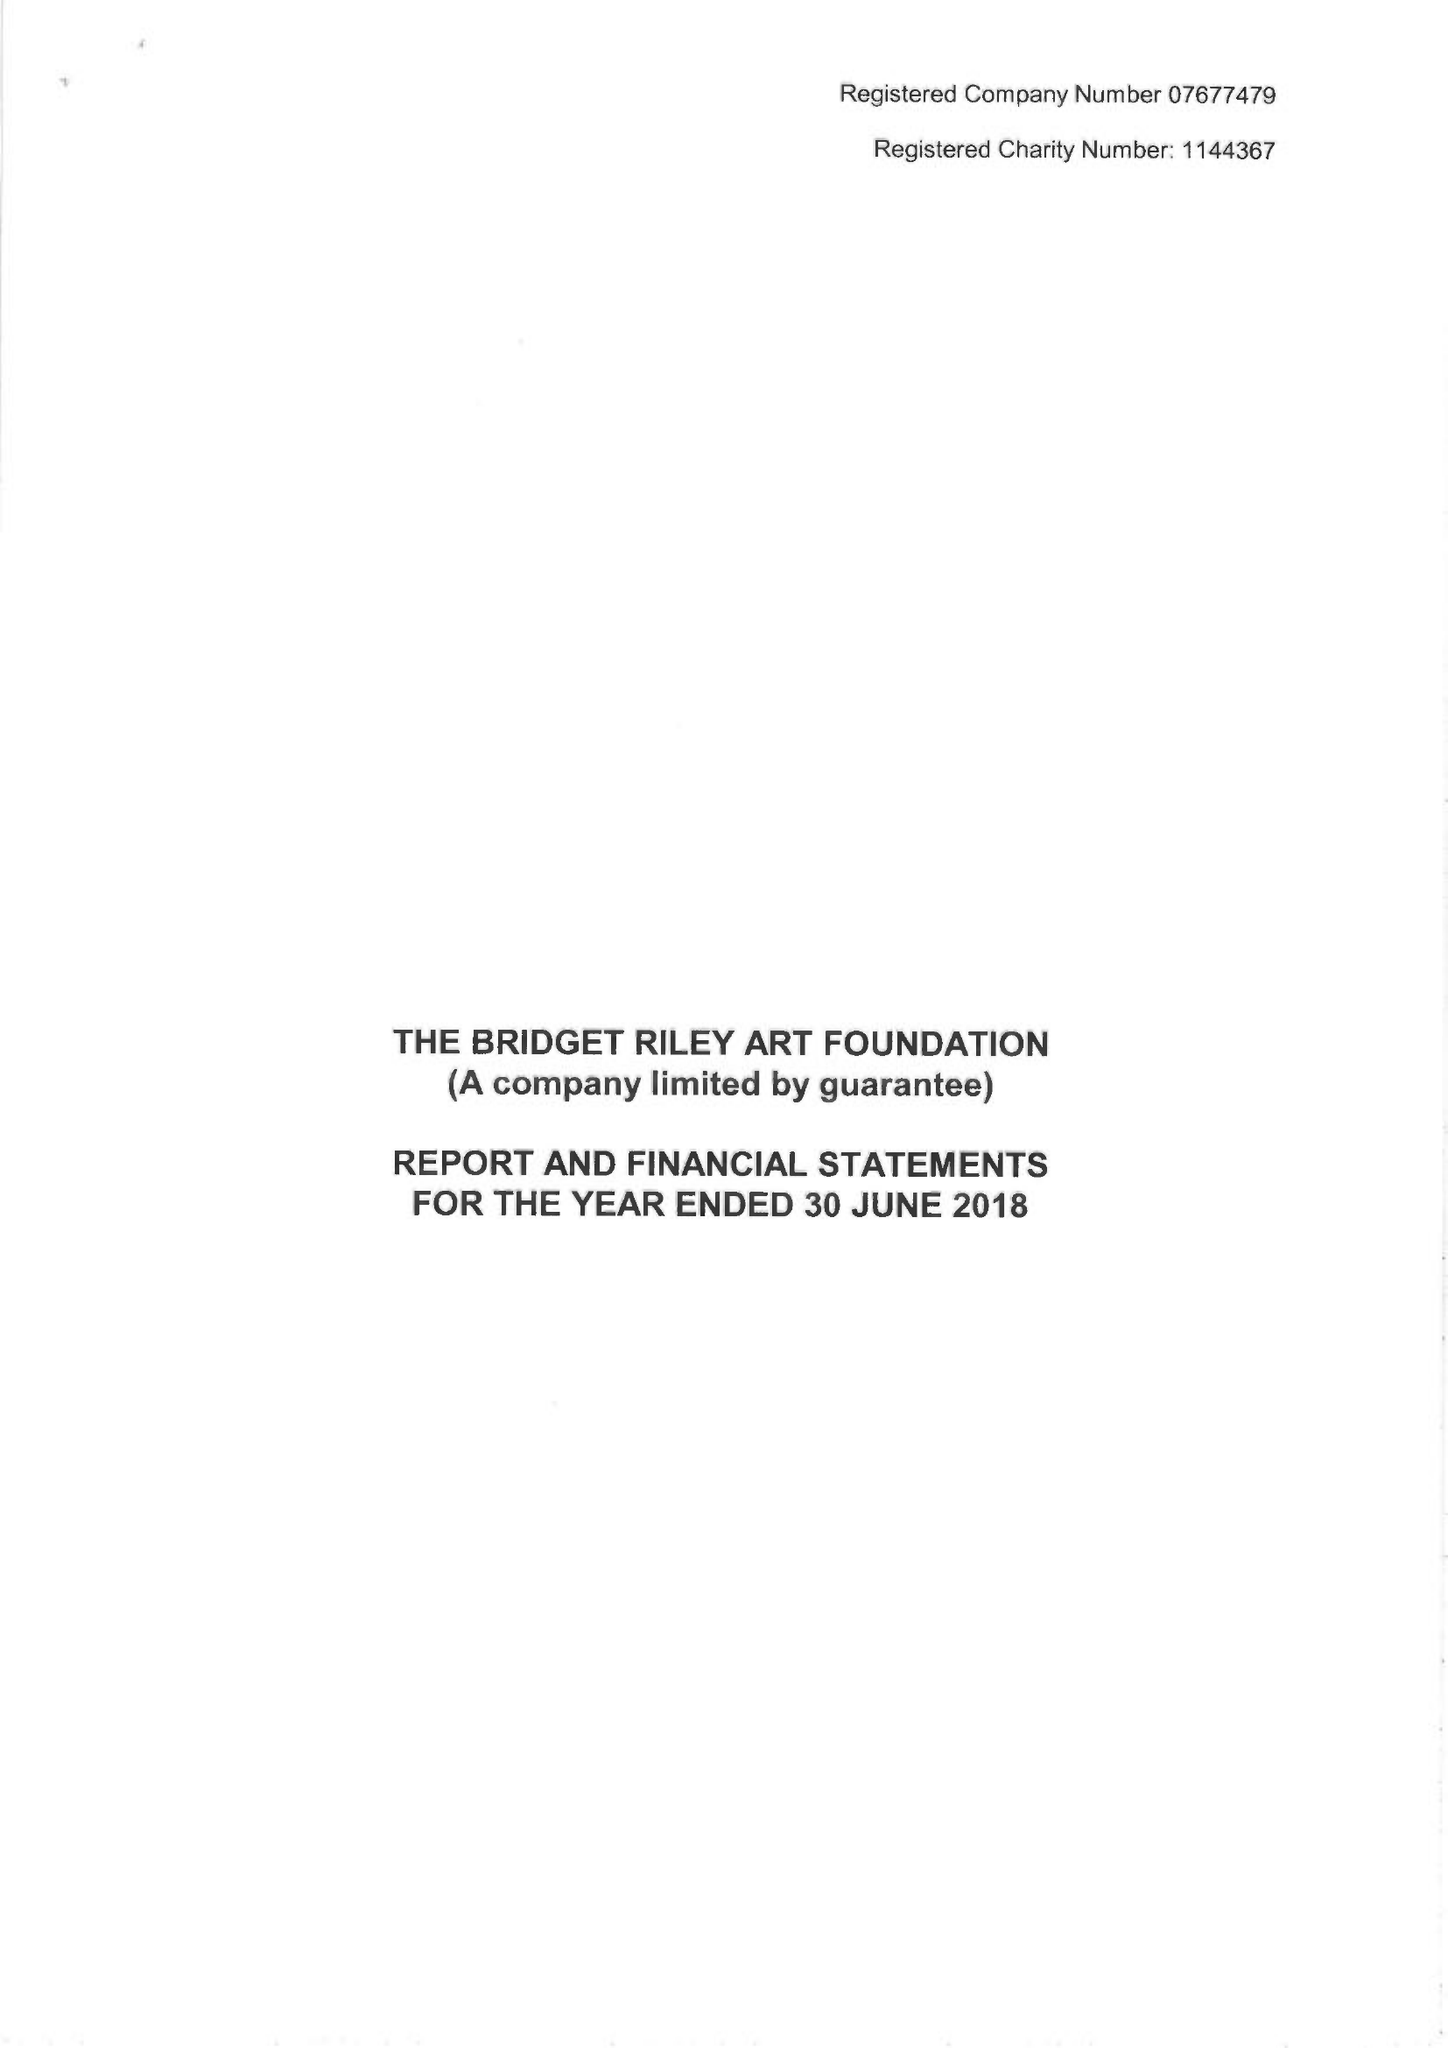What is the value for the address__post_town?
Answer the question using a single word or phrase. LONDON 